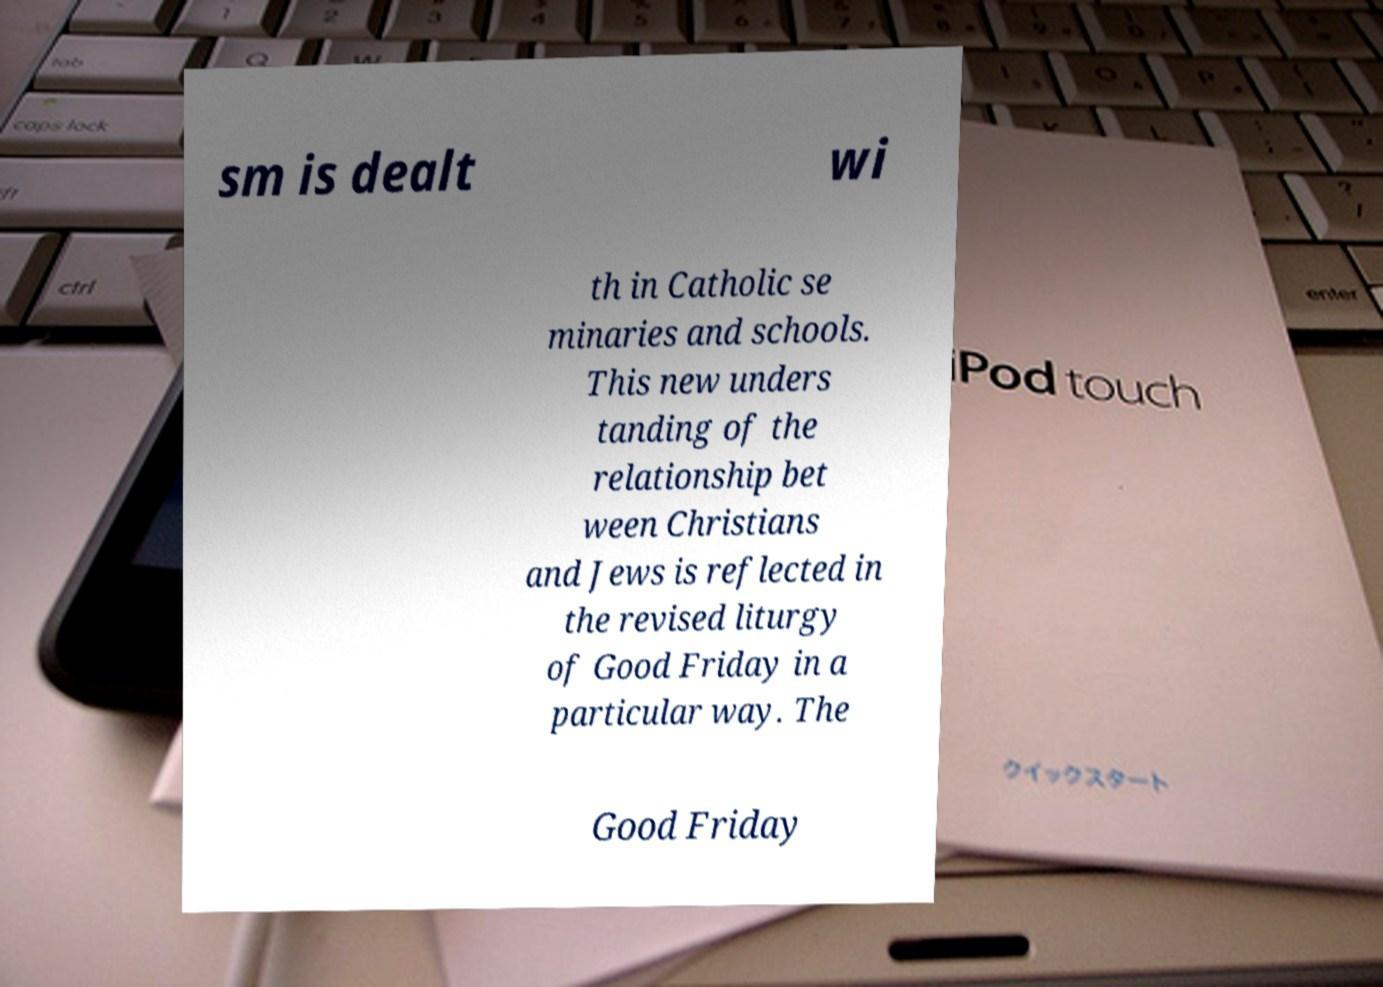There's text embedded in this image that I need extracted. Can you transcribe it verbatim? sm is dealt wi th in Catholic se minaries and schools. This new unders tanding of the relationship bet ween Christians and Jews is reflected in the revised liturgy of Good Friday in a particular way. The Good Friday 